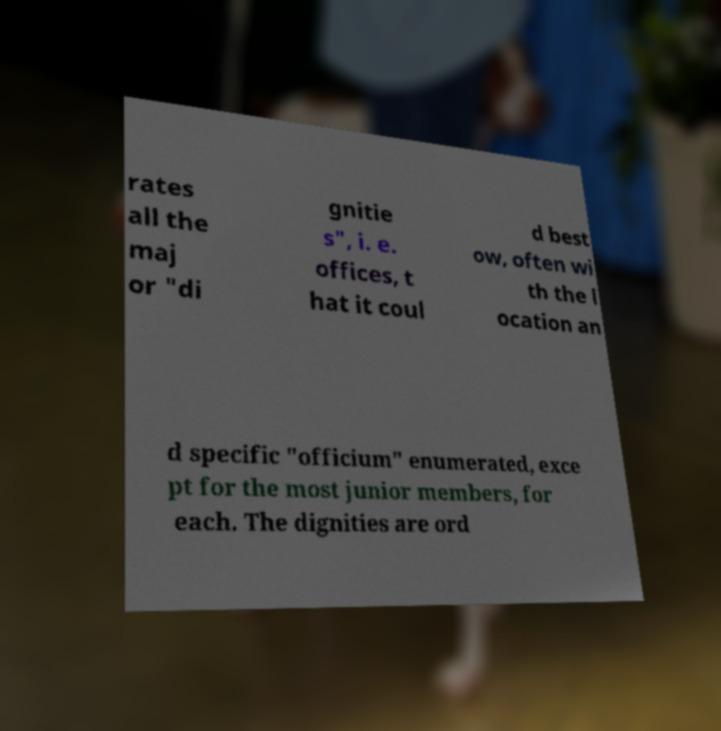What messages or text are displayed in this image? I need them in a readable, typed format. rates all the maj or "di gnitie s", i. e. offices, t hat it coul d best ow, often wi th the l ocation an d specific "officium" enumerated, exce pt for the most junior members, for each. The dignities are ord 